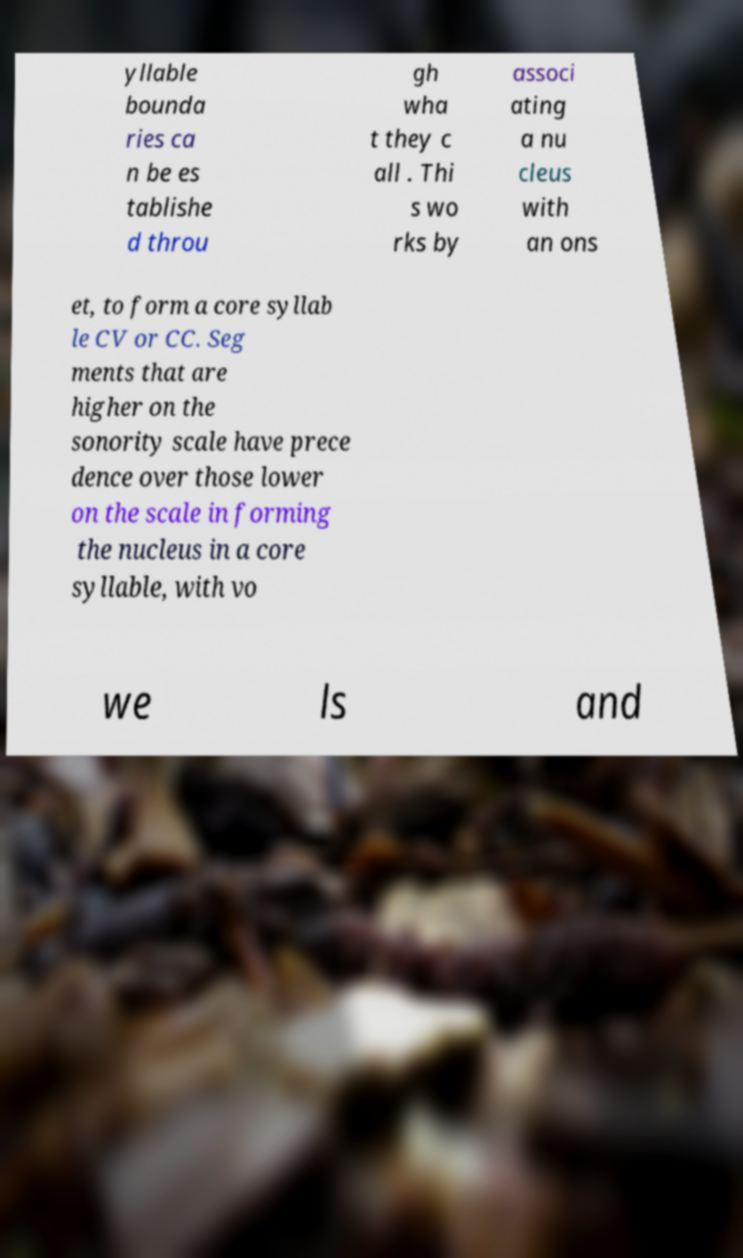Could you extract and type out the text from this image? yllable bounda ries ca n be es tablishe d throu gh wha t they c all . Thi s wo rks by associ ating a nu cleus with an ons et, to form a core syllab le CV or CC. Seg ments that are higher on the sonority scale have prece dence over those lower on the scale in forming the nucleus in a core syllable, with vo we ls and 